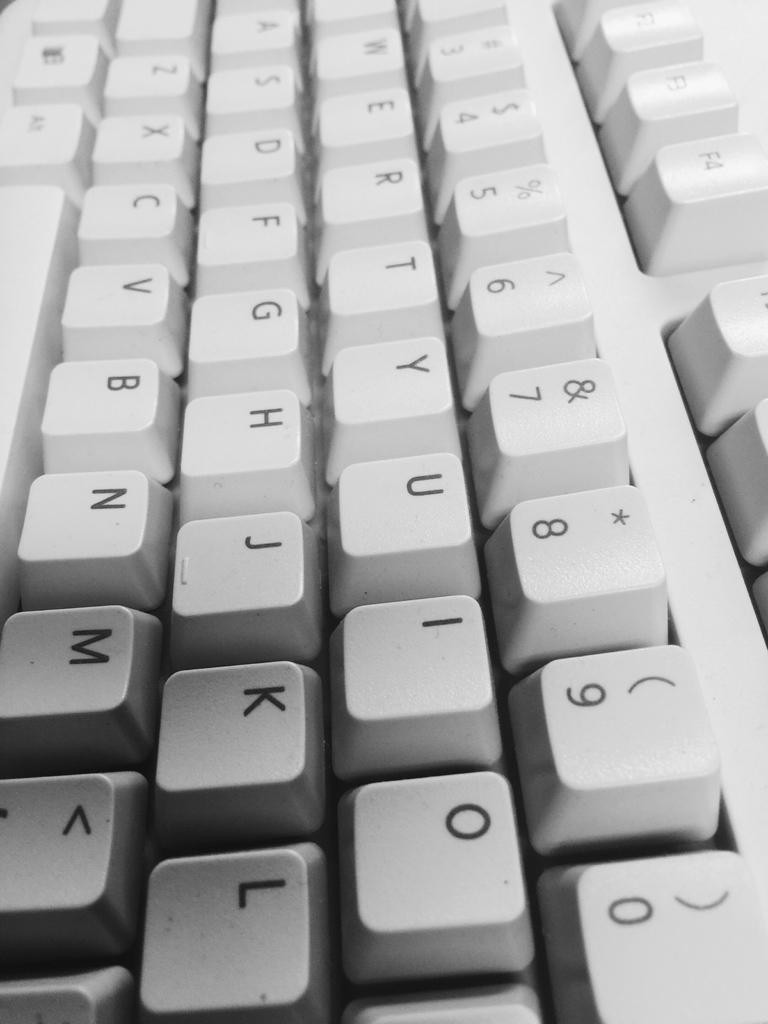<image>
Present a compact description of the photo's key features. A gray qwerty keyboard is shown up close. 